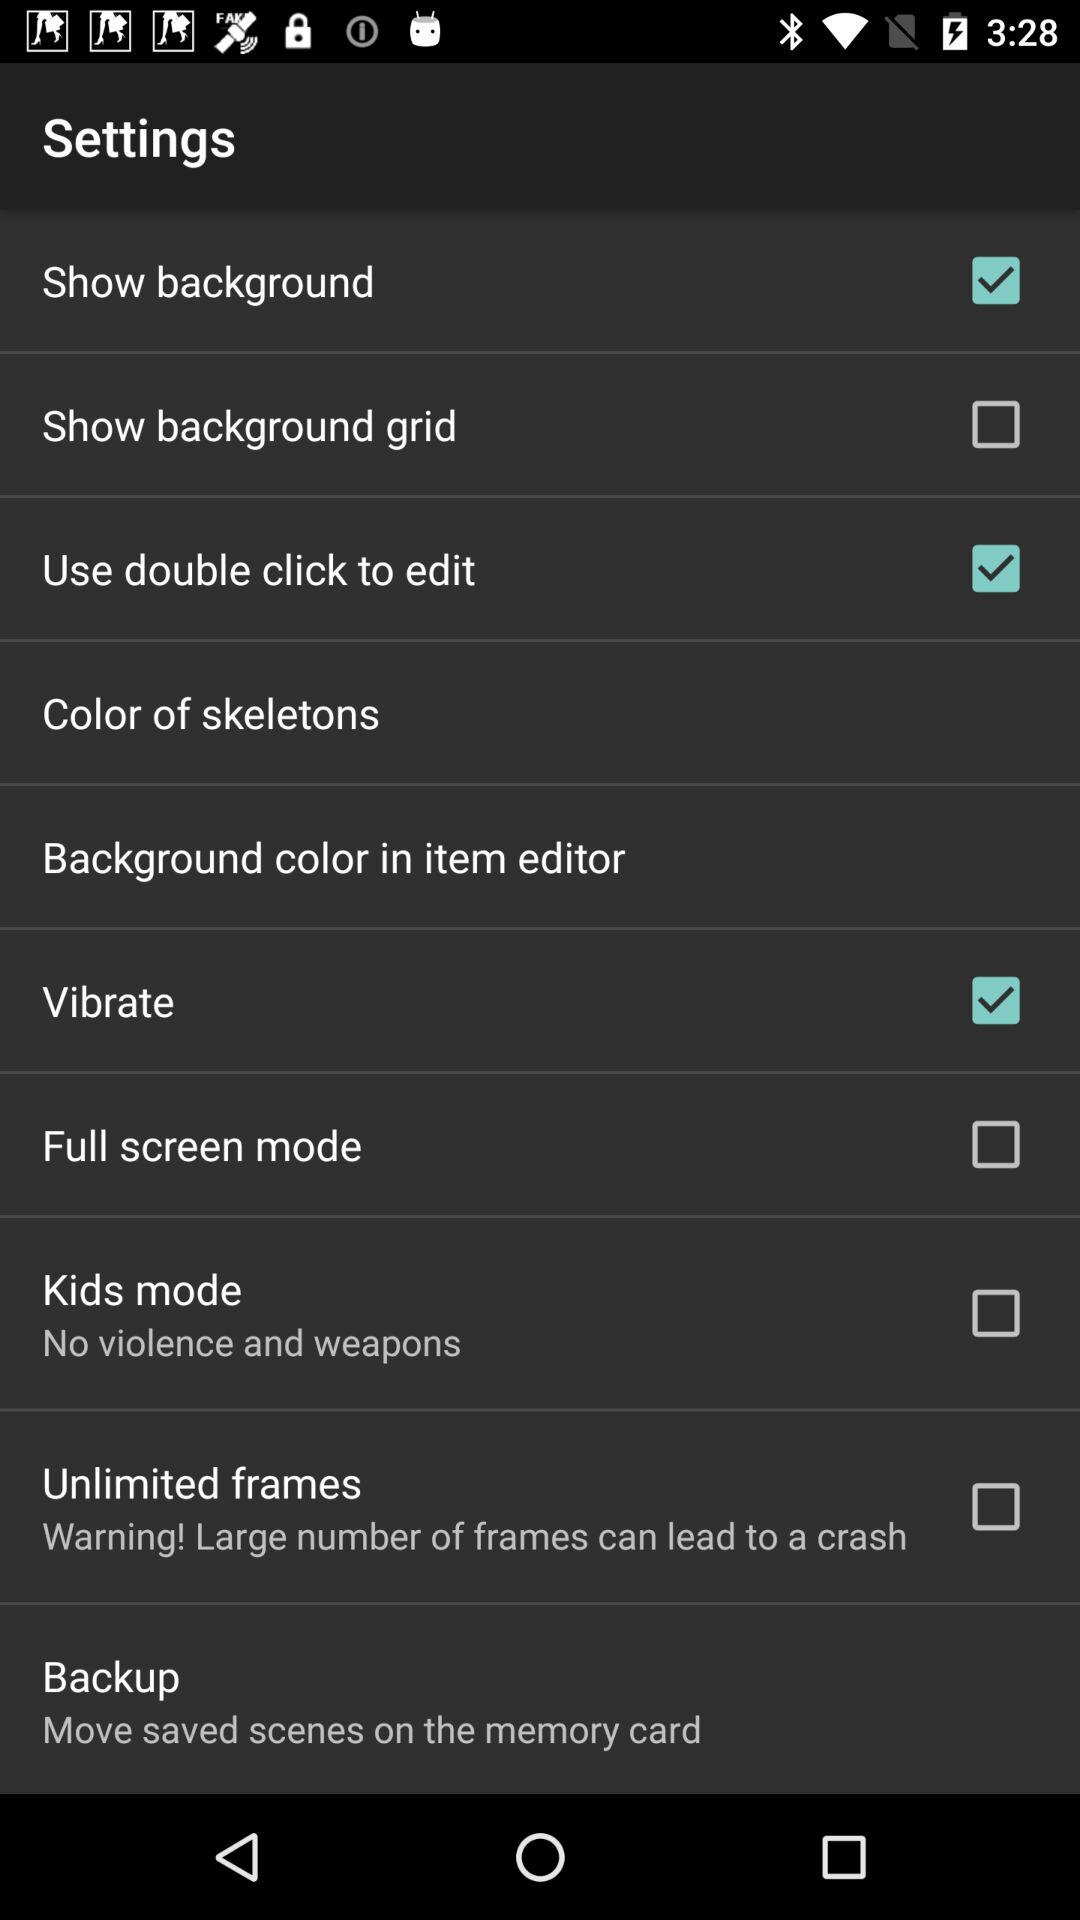What is the warning in the unlimited frames? The warning in the unlimited frames is "Large number of frames can lead to a crash". 